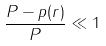Convert formula to latex. <formula><loc_0><loc_0><loc_500><loc_500>\frac { P - p ( r ) } { P } \ll 1</formula> 